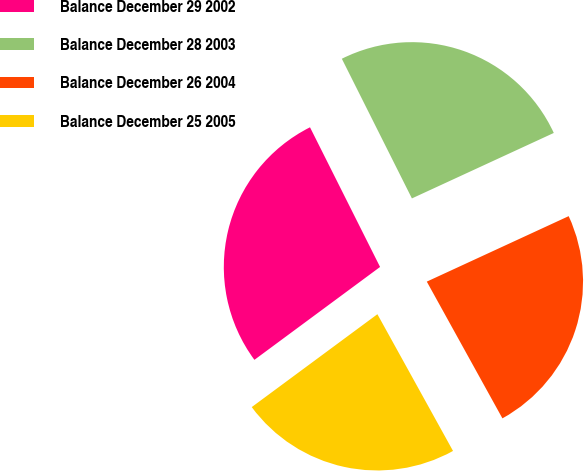Convert chart to OTSL. <chart><loc_0><loc_0><loc_500><loc_500><pie_chart><fcel>Balance December 29 2002<fcel>Balance December 28 2003<fcel>Balance December 26 2004<fcel>Balance December 25 2005<nl><fcel>27.73%<fcel>25.52%<fcel>23.84%<fcel>22.91%<nl></chart> 